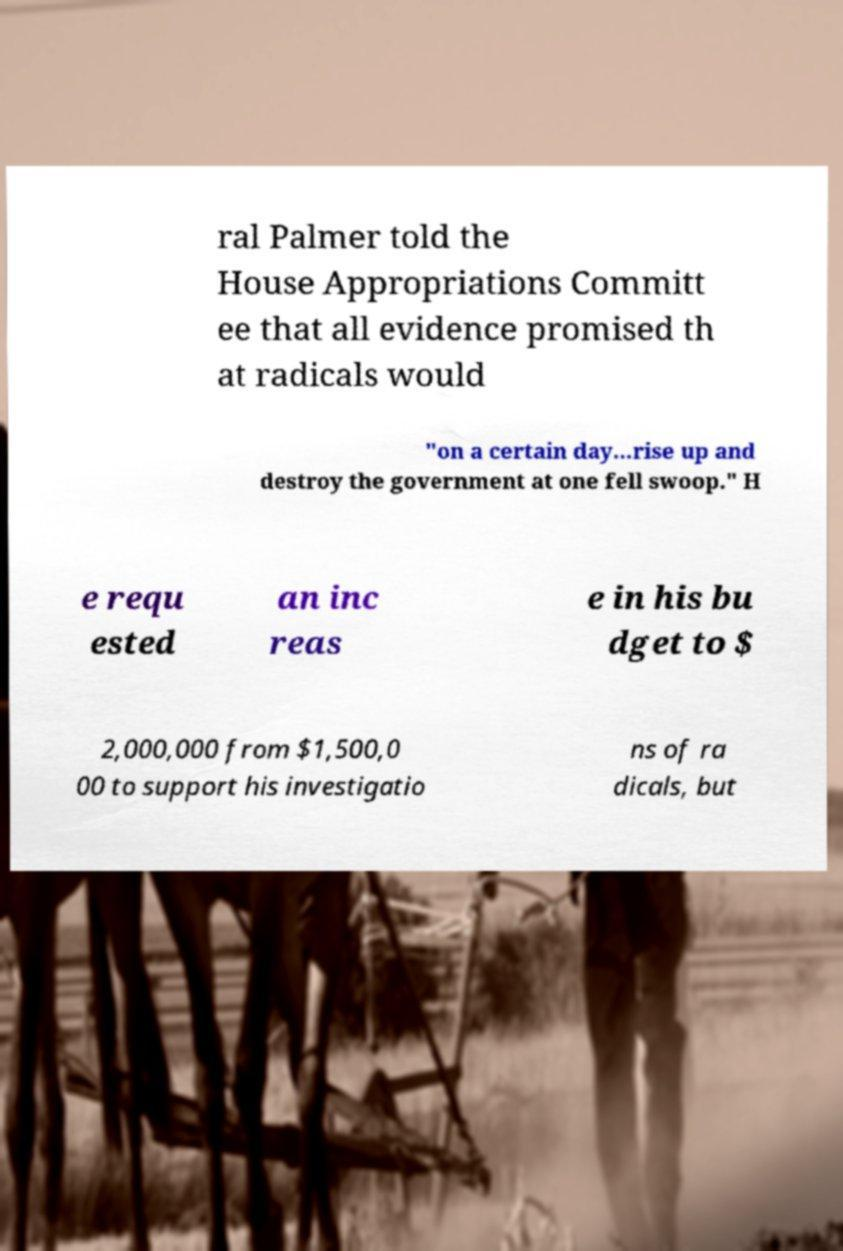Please read and relay the text visible in this image. What does it say? ral Palmer told the House Appropriations Committ ee that all evidence promised th at radicals would "on a certain day...rise up and destroy the government at one fell swoop." H e requ ested an inc reas e in his bu dget to $ 2,000,000 from $1,500,0 00 to support his investigatio ns of ra dicals, but 